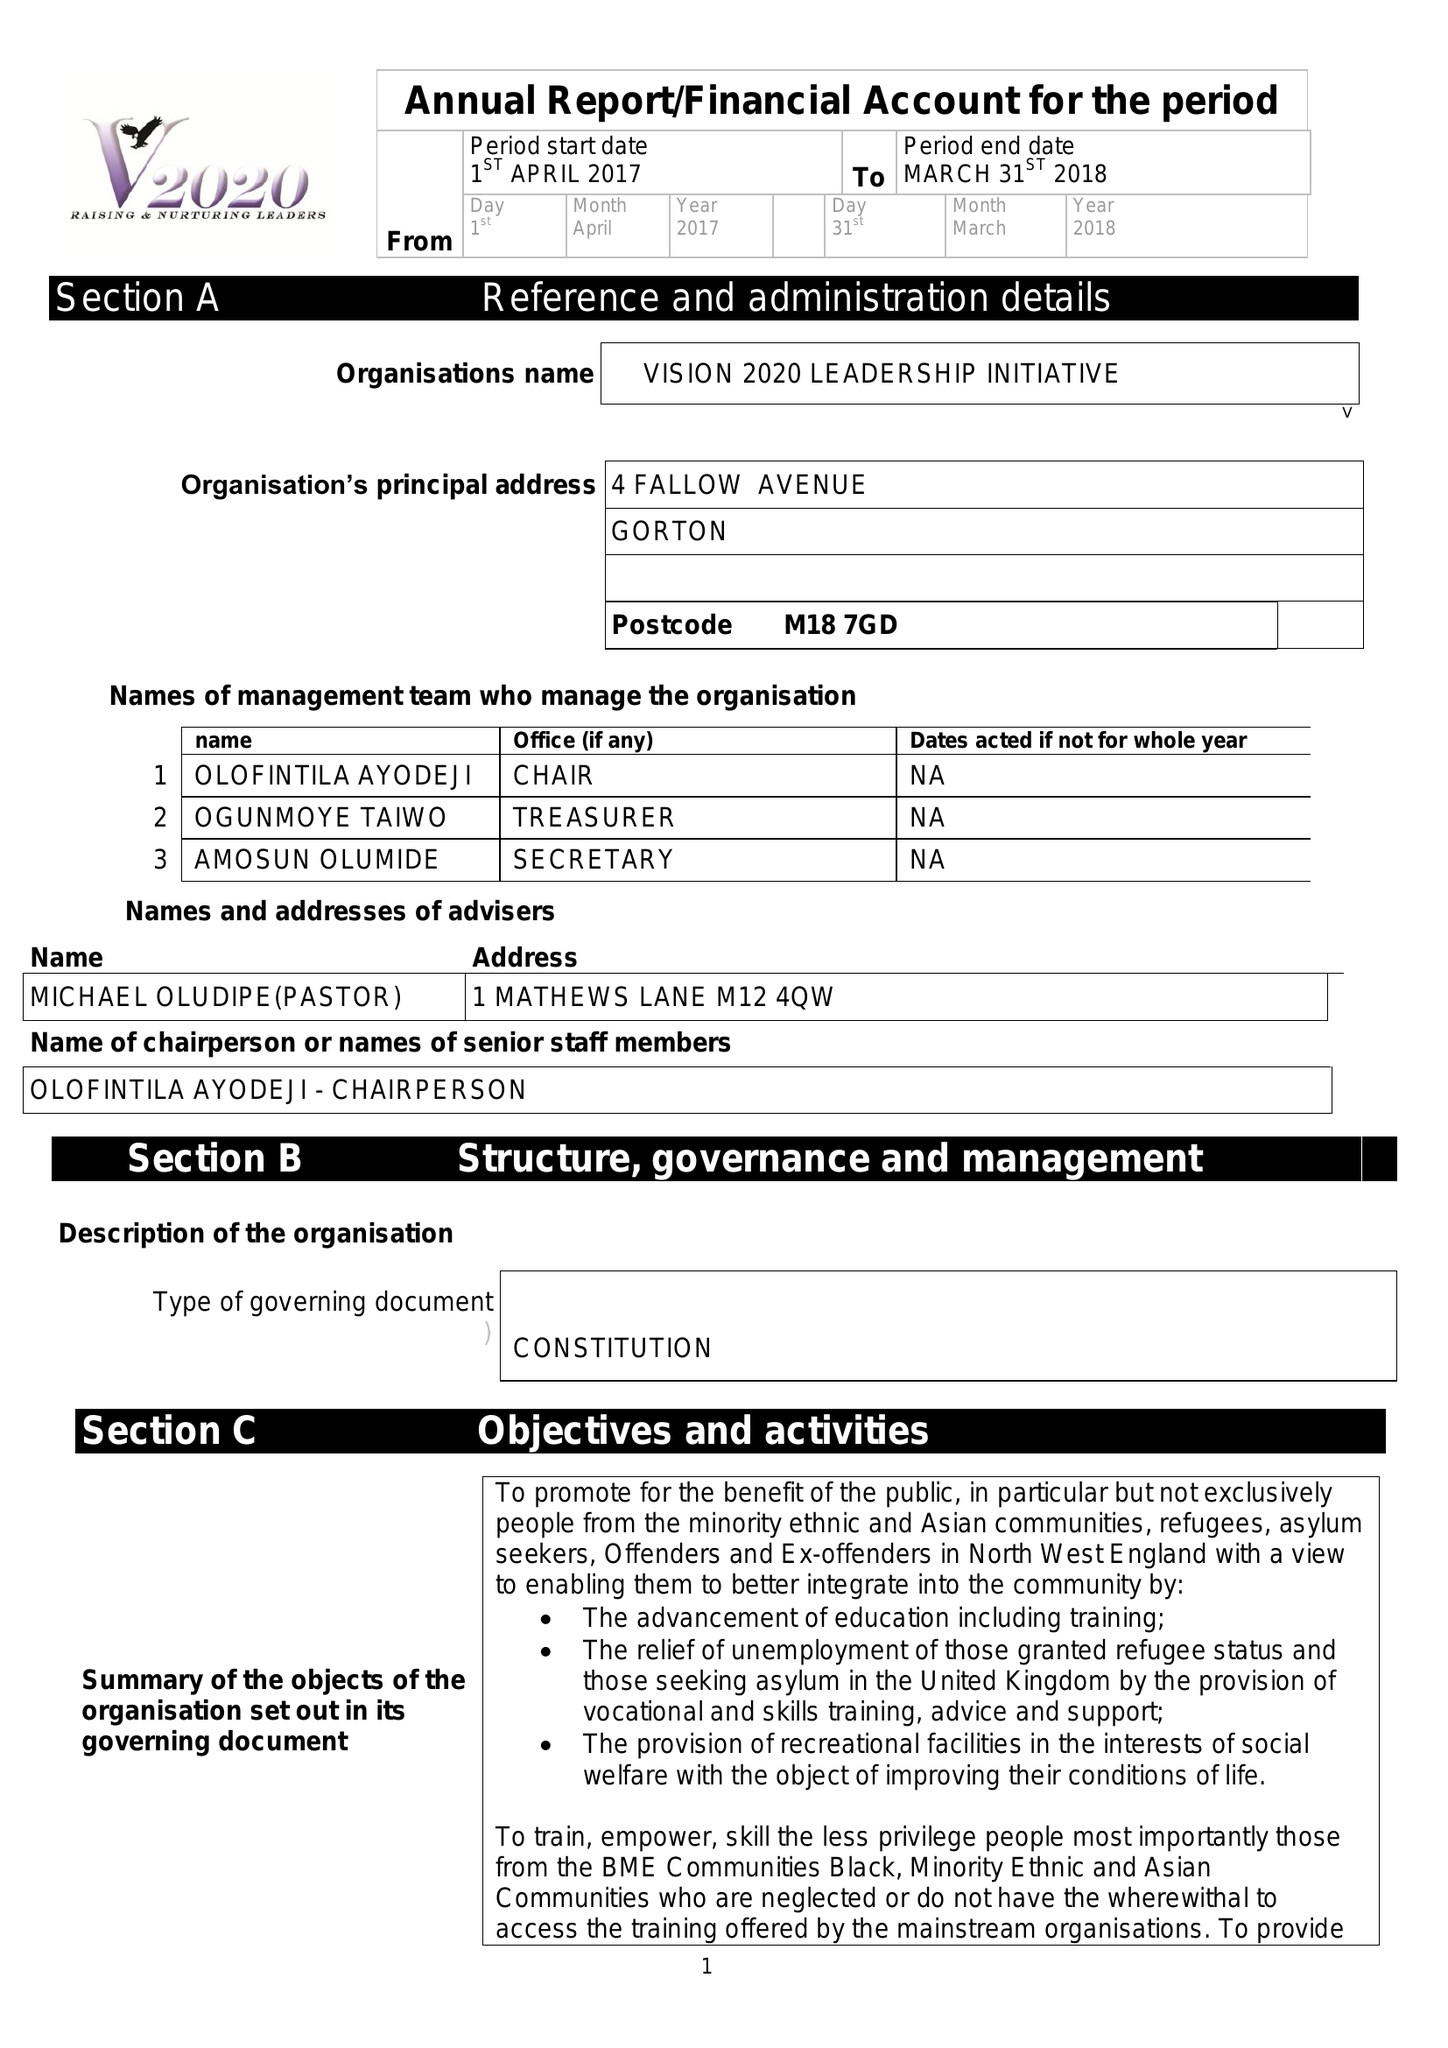What is the value for the charity_name?
Answer the question using a single word or phrase. Vision 2020 Leadership Initiative 